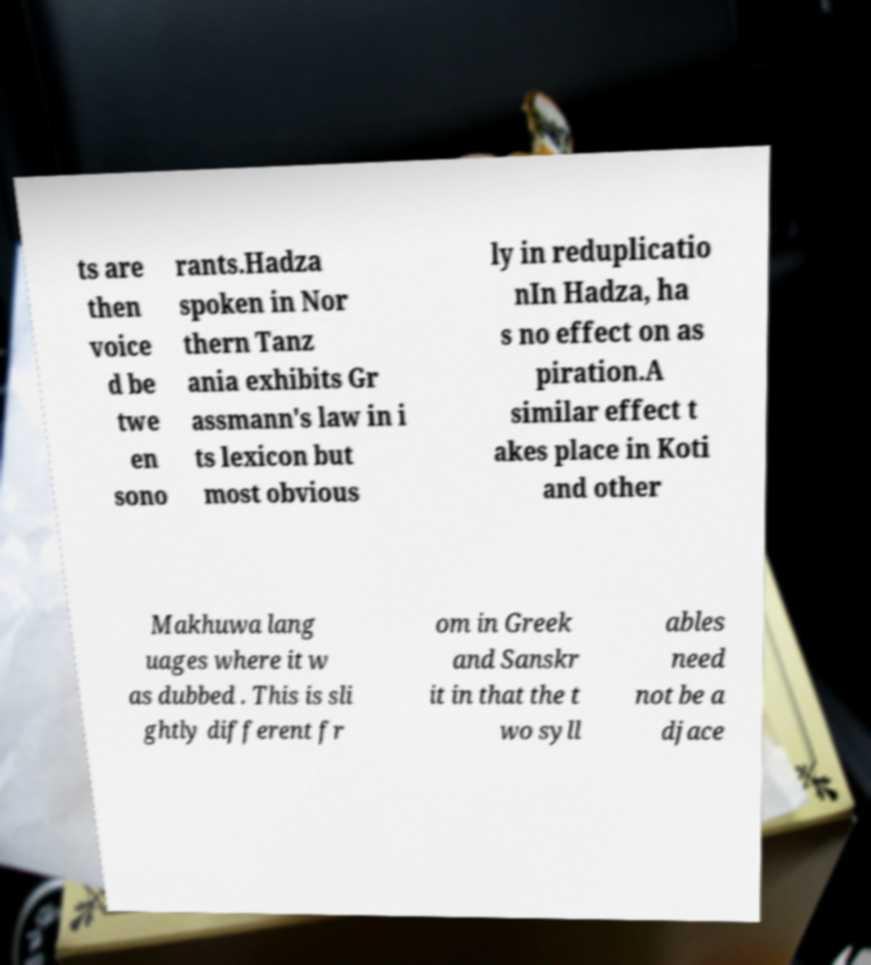I need the written content from this picture converted into text. Can you do that? ts are then voice d be twe en sono rants.Hadza spoken in Nor thern Tanz ania exhibits Gr assmann's law in i ts lexicon but most obvious ly in reduplicatio nIn Hadza, ha s no effect on as piration.A similar effect t akes place in Koti and other Makhuwa lang uages where it w as dubbed . This is sli ghtly different fr om in Greek and Sanskr it in that the t wo syll ables need not be a djace 